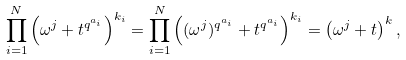Convert formula to latex. <formula><loc_0><loc_0><loc_500><loc_500>\prod _ { i = 1 } ^ { N } \left ( \omega ^ { j } + t ^ { q ^ { a _ { i } } } \right ) ^ { k _ { i } } = \prod _ { i = 1 } ^ { N } \left ( ( \omega ^ { j } ) ^ { q ^ { a _ { i } } } + t ^ { q ^ { a _ { i } } } \right ) ^ { k _ { i } } = \left ( \omega ^ { j } + t \right ) ^ { k } ,</formula> 